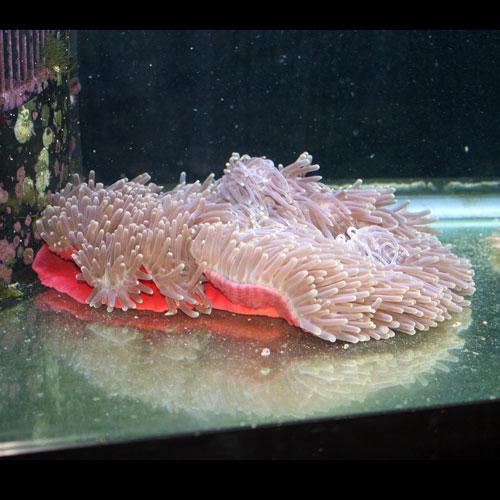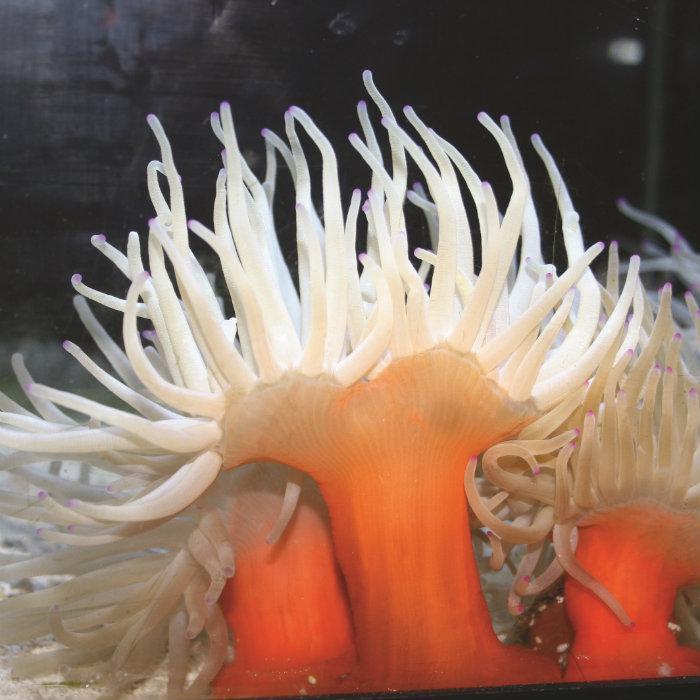The first image is the image on the left, the second image is the image on the right. Assess this claim about the two images: "An image shows a neutral-colored anemone with sky blue background.". Correct or not? Answer yes or no. No. The first image is the image on the left, the second image is the image on the right. Assess this claim about the two images: "the anemone in one of the images is very wide". Correct or not? Answer yes or no. Yes. 